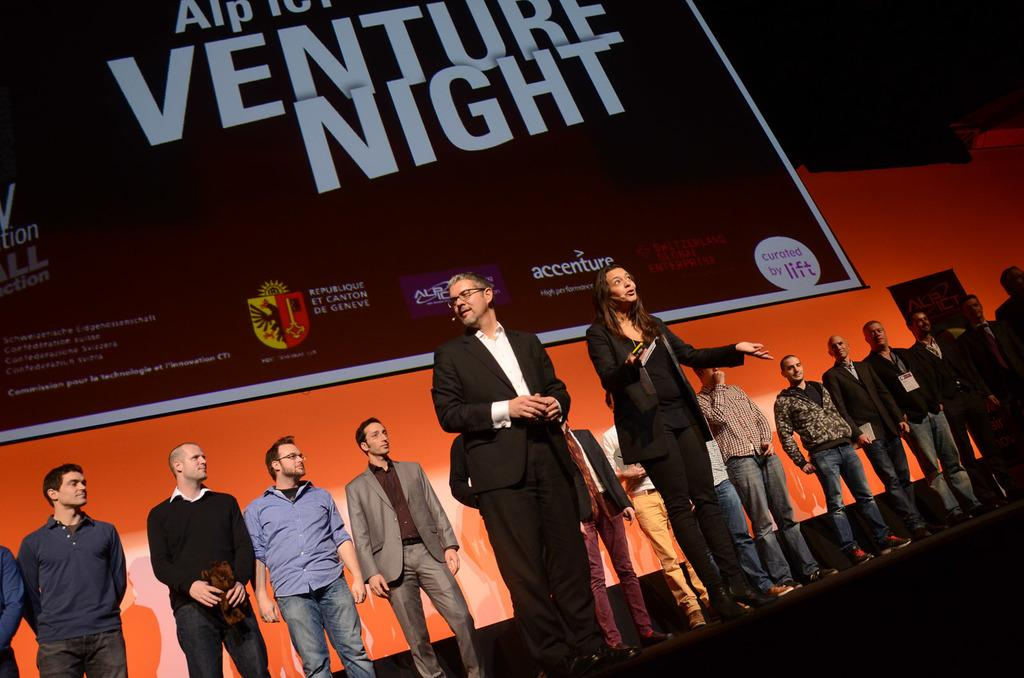What is happening in the image? There are people standing on the stage in the image. Can you describe the individuals on the stage? There are both men and women in the image. What can be seen in the background of the image? There is a large poster in the background of the image. What color is the poster? The poster is maroon in color. Can you tell me how many babies are holding spoons on the stage in the image? There are no babies or spoons present in the image; it features people standing on the stage with a maroon poster in the background. 